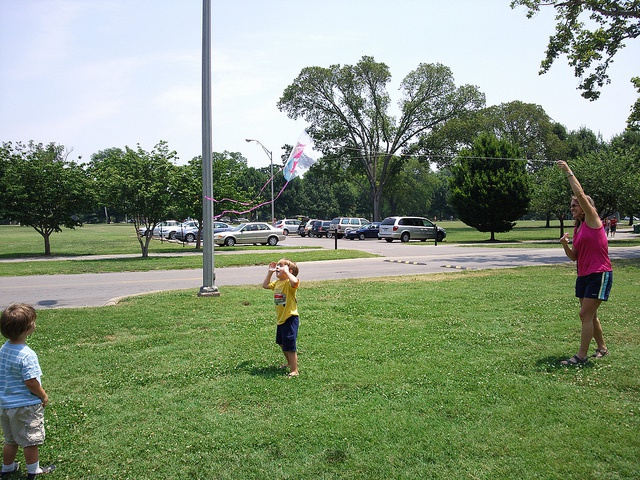Describe the objects in this image and their specific colors. I can see people in lavender, gray, black, and maroon tones, people in lavender, maroon, black, darkgreen, and gray tones, people in lavender, black, and olive tones, car in lavender, black, gray, darkgray, and white tones, and car in lavender, gray, white, darkgray, and black tones in this image. 